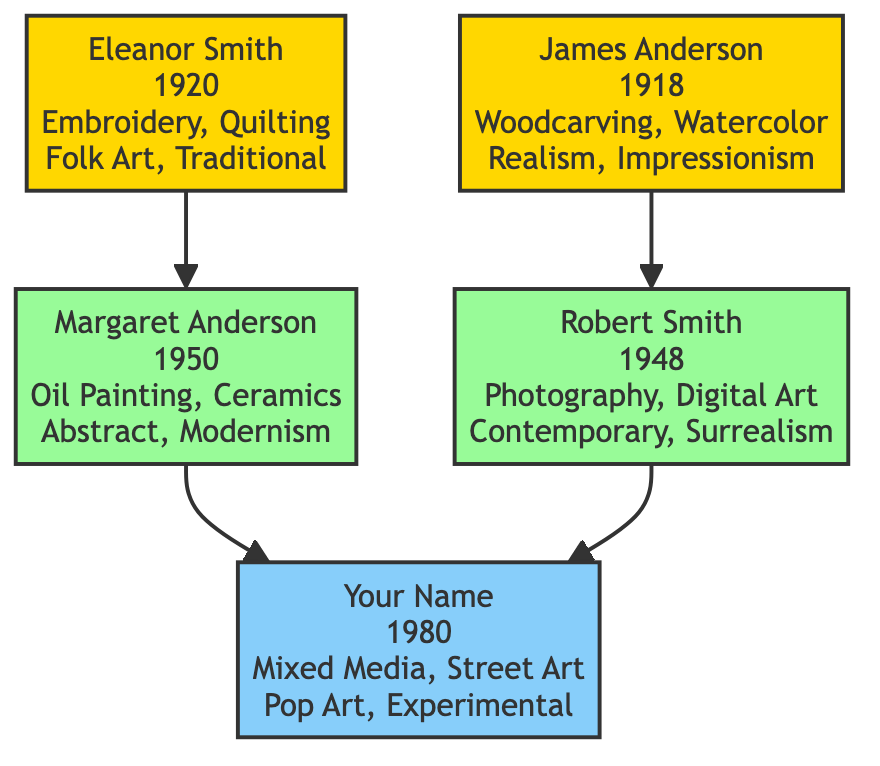What is the birth year of Eleanor Smith? The diagram states that Eleanor Smith is born in the year 1920, as indicated in her node.
Answer: 1920 What mediums did James Anderson use? The diagram lists the mediums associated with James Anderson as Woodcarving and Watercolor Painting, shown in his node.
Answer: Woodcarving, Watercolor Painting How many key artworks did Margaret Anderson create? By looking at Margaret Anderson's node, we see she created two key artworks: "Autumn Leaves" and "Ceramic Vase Collection," which informs us of the total count.
Answer: 2 Which artistic style is associated with Robert Smith? In Robert Smith's node, the diagram specifies that his styles include Contemporary and Surrealism, meaning one of those styles is the answer.
Answer: Contemporary, Surrealism Who is the parent of Your Name in the diagram? The node for Your Name shows directed connections from both parents, identifying Margaret Anderson and Robert Smith as the parents.
Answer: Margaret Anderson, Robert Smith What is the medium used by Your Name? The node for Your Name mentions Mixed Media and Street Art as the mediums used, confirming this information directly from the diagram.
Answer: Mixed Media, Street Art Which grandparent used quilting as a medium? The diagram shows that Eleanor Smith is associated with the medium of Quilting, which is detailed in her node.
Answer: Eleanor Smith How many generations are represented in the diagram? The diagram has three distinct generational groups: Grandparents, Parents, and You, which can be counted for the total number of generational layers.
Answer: 3 Which key artwork is associated with Robert Smith? The diagram identifies two key artworks associated with Robert Smith: "Steel City Nights" and "Digital Portrait Series," confirming one as an answer.
Answer: Steel City Nights, Digital Portrait Series 